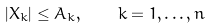<formula> <loc_0><loc_0><loc_500><loc_500>| X _ { k } | \leq A _ { k } , \quad k = 1 , \dots , n</formula> 